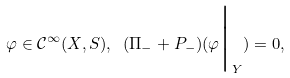Convert formula to latex. <formula><loc_0><loc_0><loc_500><loc_500>\varphi \in \mathcal { C } ^ { \infty } ( X , S ) , \ ( \Pi _ { - } + P _ { - } ) ( \varphi \Big | _ { Y } ) = 0 ,</formula> 